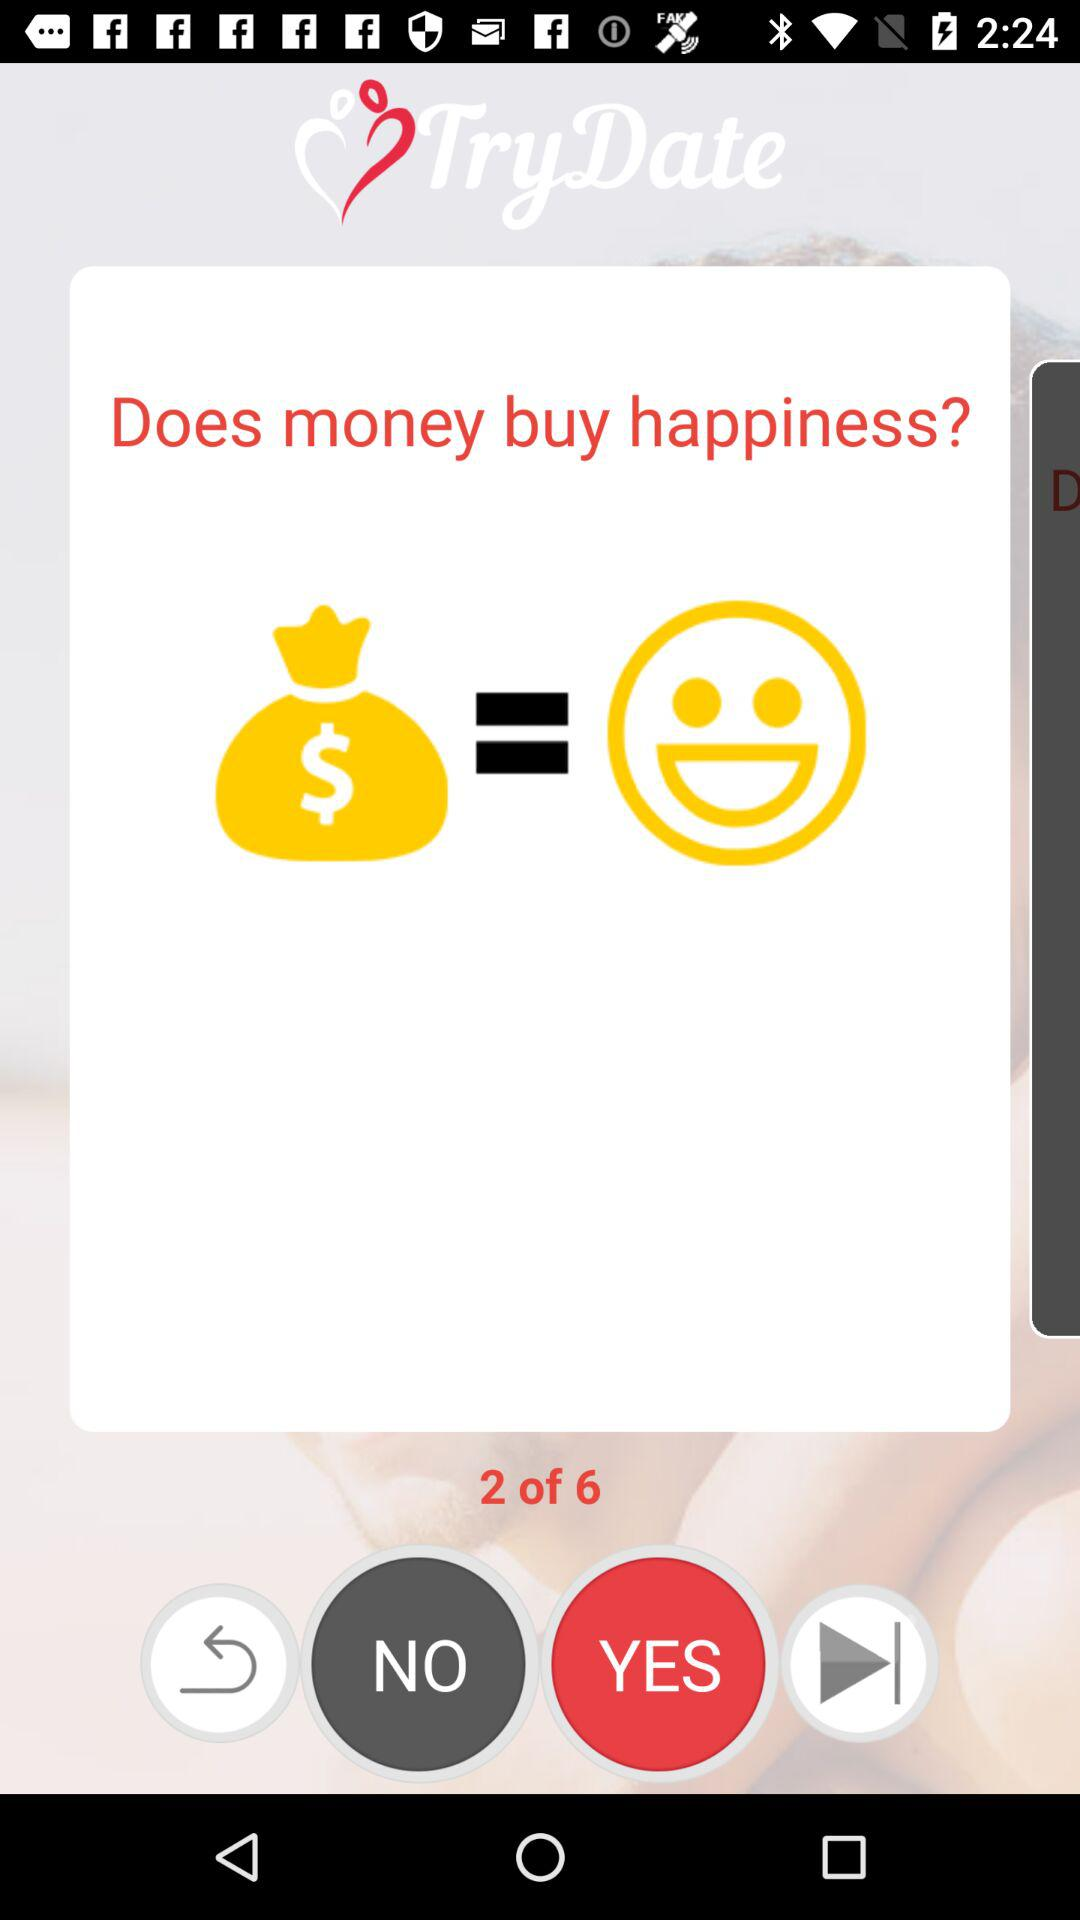What is the application name? The application name is "TryDate". 